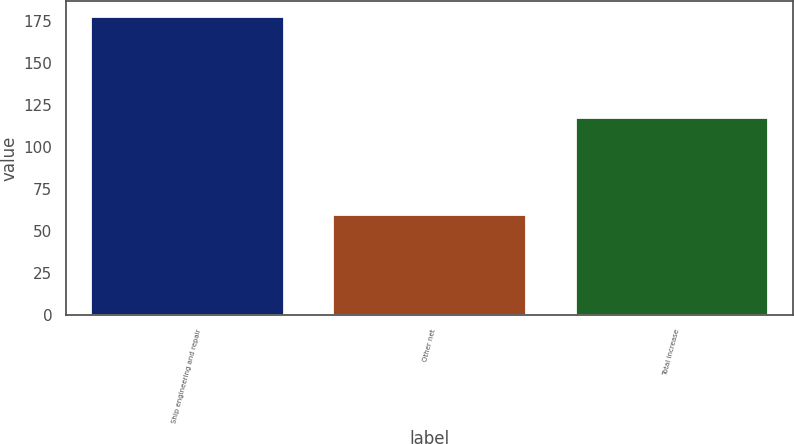Convert chart. <chart><loc_0><loc_0><loc_500><loc_500><bar_chart><fcel>Ship engineering and repair<fcel>Other net<fcel>Total increase<nl><fcel>178<fcel>60<fcel>118<nl></chart> 